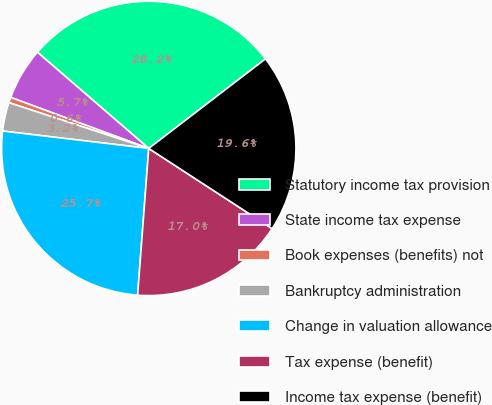Convert chart. <chart><loc_0><loc_0><loc_500><loc_500><pie_chart><fcel>Statutory income tax provision<fcel>State income tax expense<fcel>Book expenses (benefits) not<fcel>Bankruptcy administration<fcel>Change in valuation allowance<fcel>Tax expense (benefit)<fcel>Income tax expense (benefit)<nl><fcel>28.24%<fcel>5.71%<fcel>0.6%<fcel>3.15%<fcel>25.68%<fcel>17.03%<fcel>19.59%<nl></chart> 